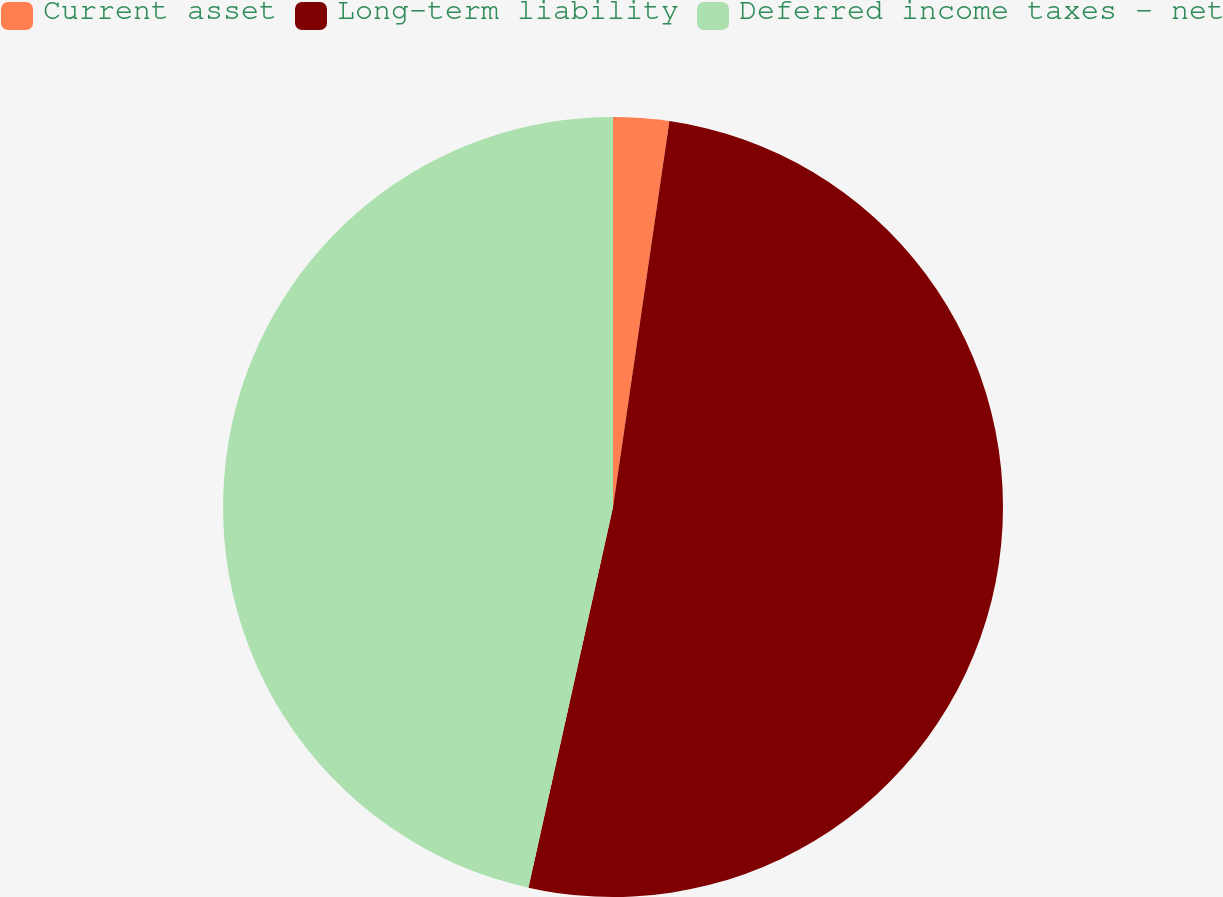Convert chart. <chart><loc_0><loc_0><loc_500><loc_500><pie_chart><fcel>Current asset<fcel>Long-term liability<fcel>Deferred income taxes - net<nl><fcel>2.31%<fcel>51.17%<fcel>46.52%<nl></chart> 